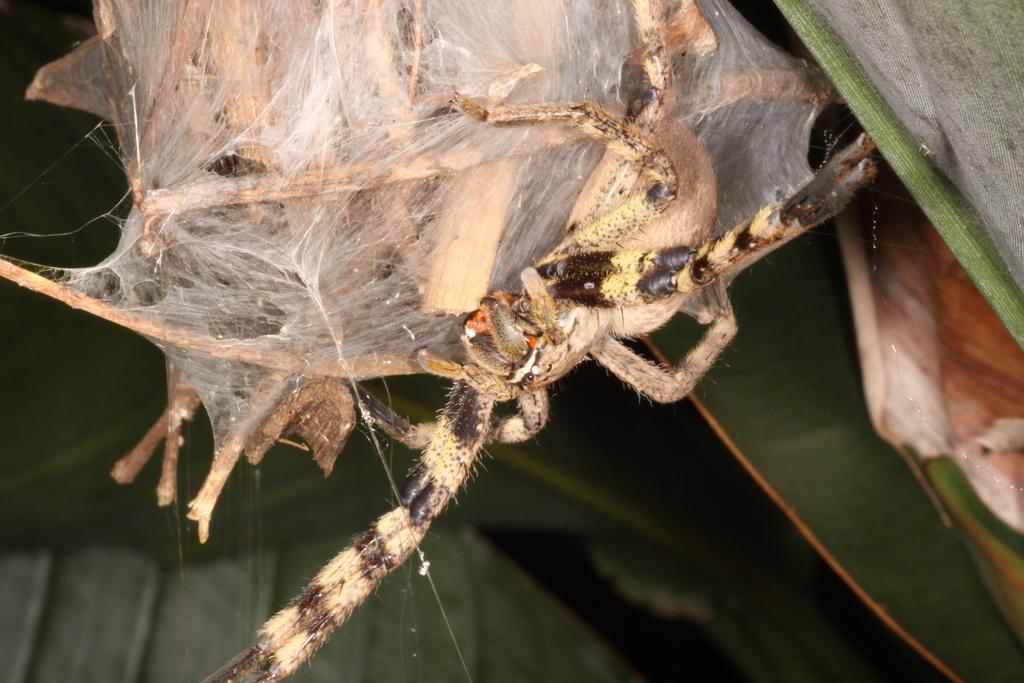How would you summarize this image in a sentence or two? This image consists of a bug. This looks like a plant. 